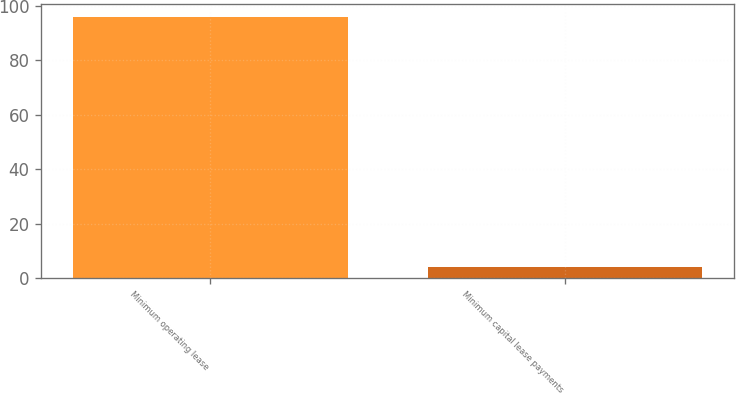Convert chart. <chart><loc_0><loc_0><loc_500><loc_500><bar_chart><fcel>Minimum operating lease<fcel>Minimum capital lease payments<nl><fcel>96<fcel>4<nl></chart> 